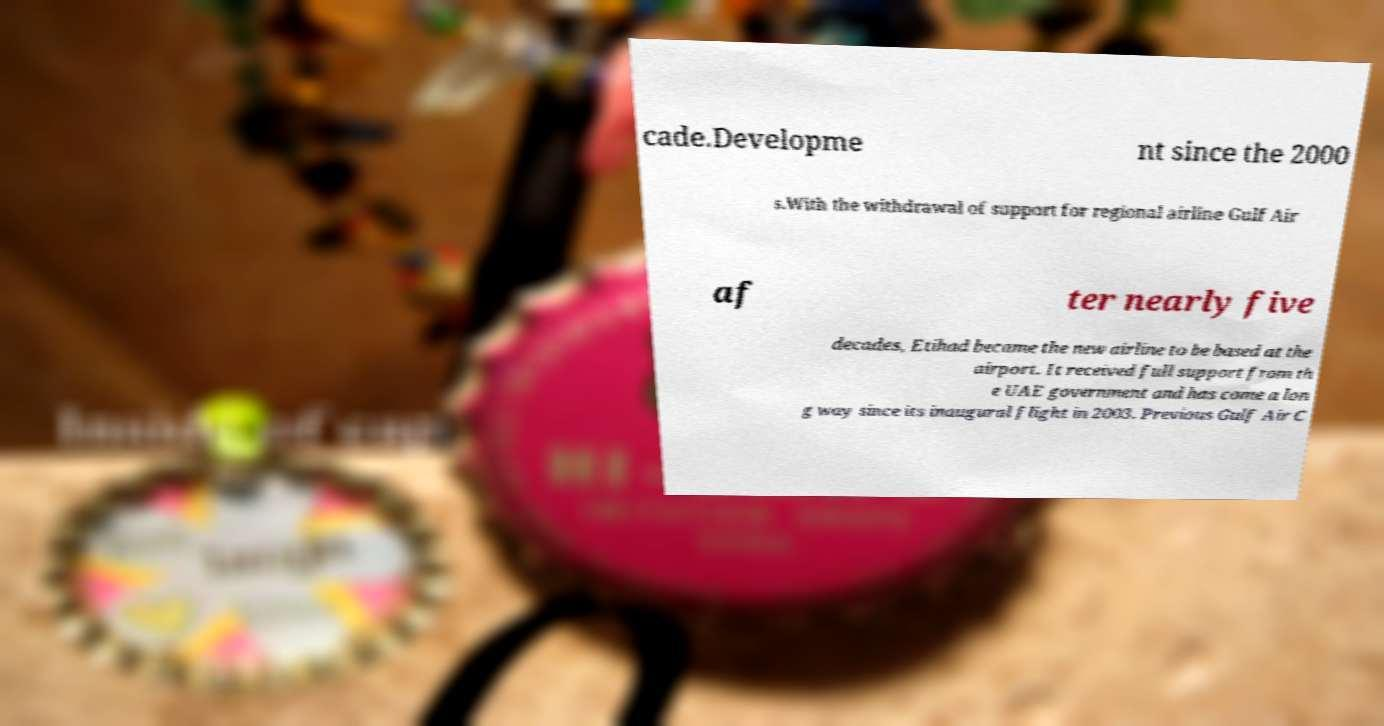What messages or text are displayed in this image? I need them in a readable, typed format. cade.Developme nt since the 2000 s.With the withdrawal of support for regional airline Gulf Air af ter nearly five decades, Etihad became the new airline to be based at the airport. It received full support from th e UAE government and has come a lon g way since its inaugural flight in 2003. Previous Gulf Air C 